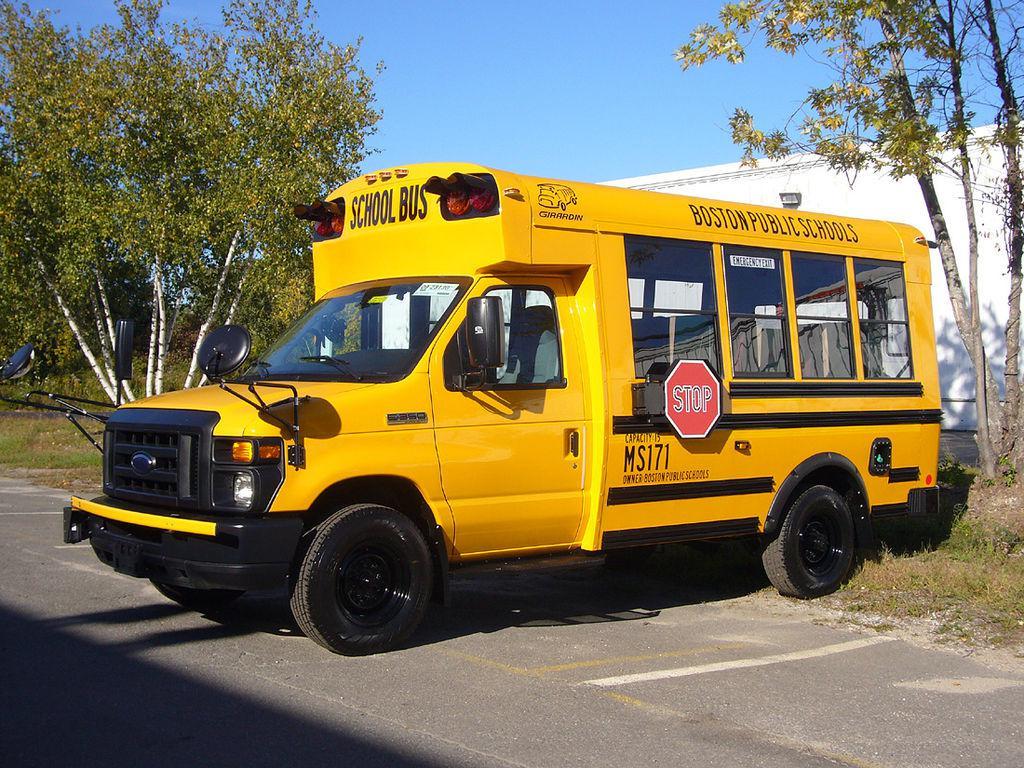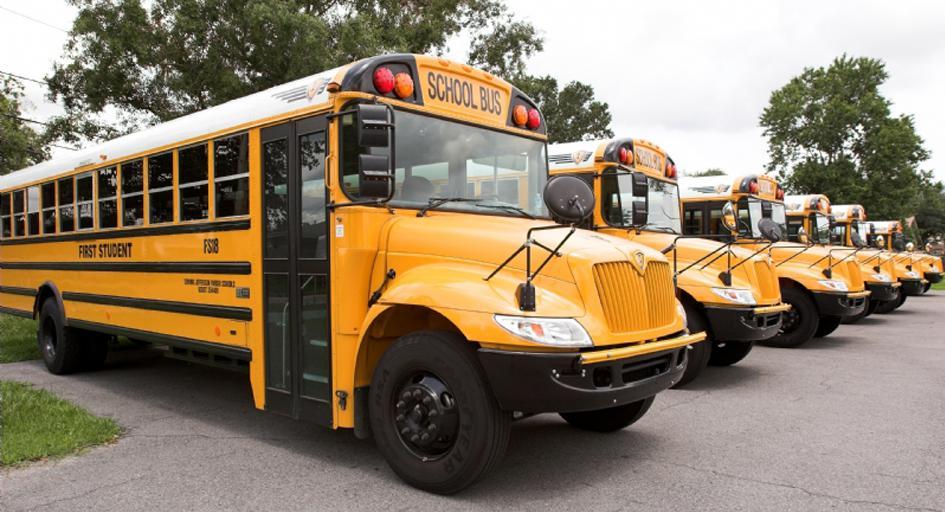The first image is the image on the left, the second image is the image on the right. For the images displayed, is the sentence "A short school bus with no more than four windows in the body side has standard wide turning mirrors at the front of the hood." factually correct? Answer yes or no. Yes. The first image is the image on the left, the second image is the image on the right. Assess this claim about the two images: "Buses are lined up side by side in at least one of the images.". Correct or not? Answer yes or no. Yes. 